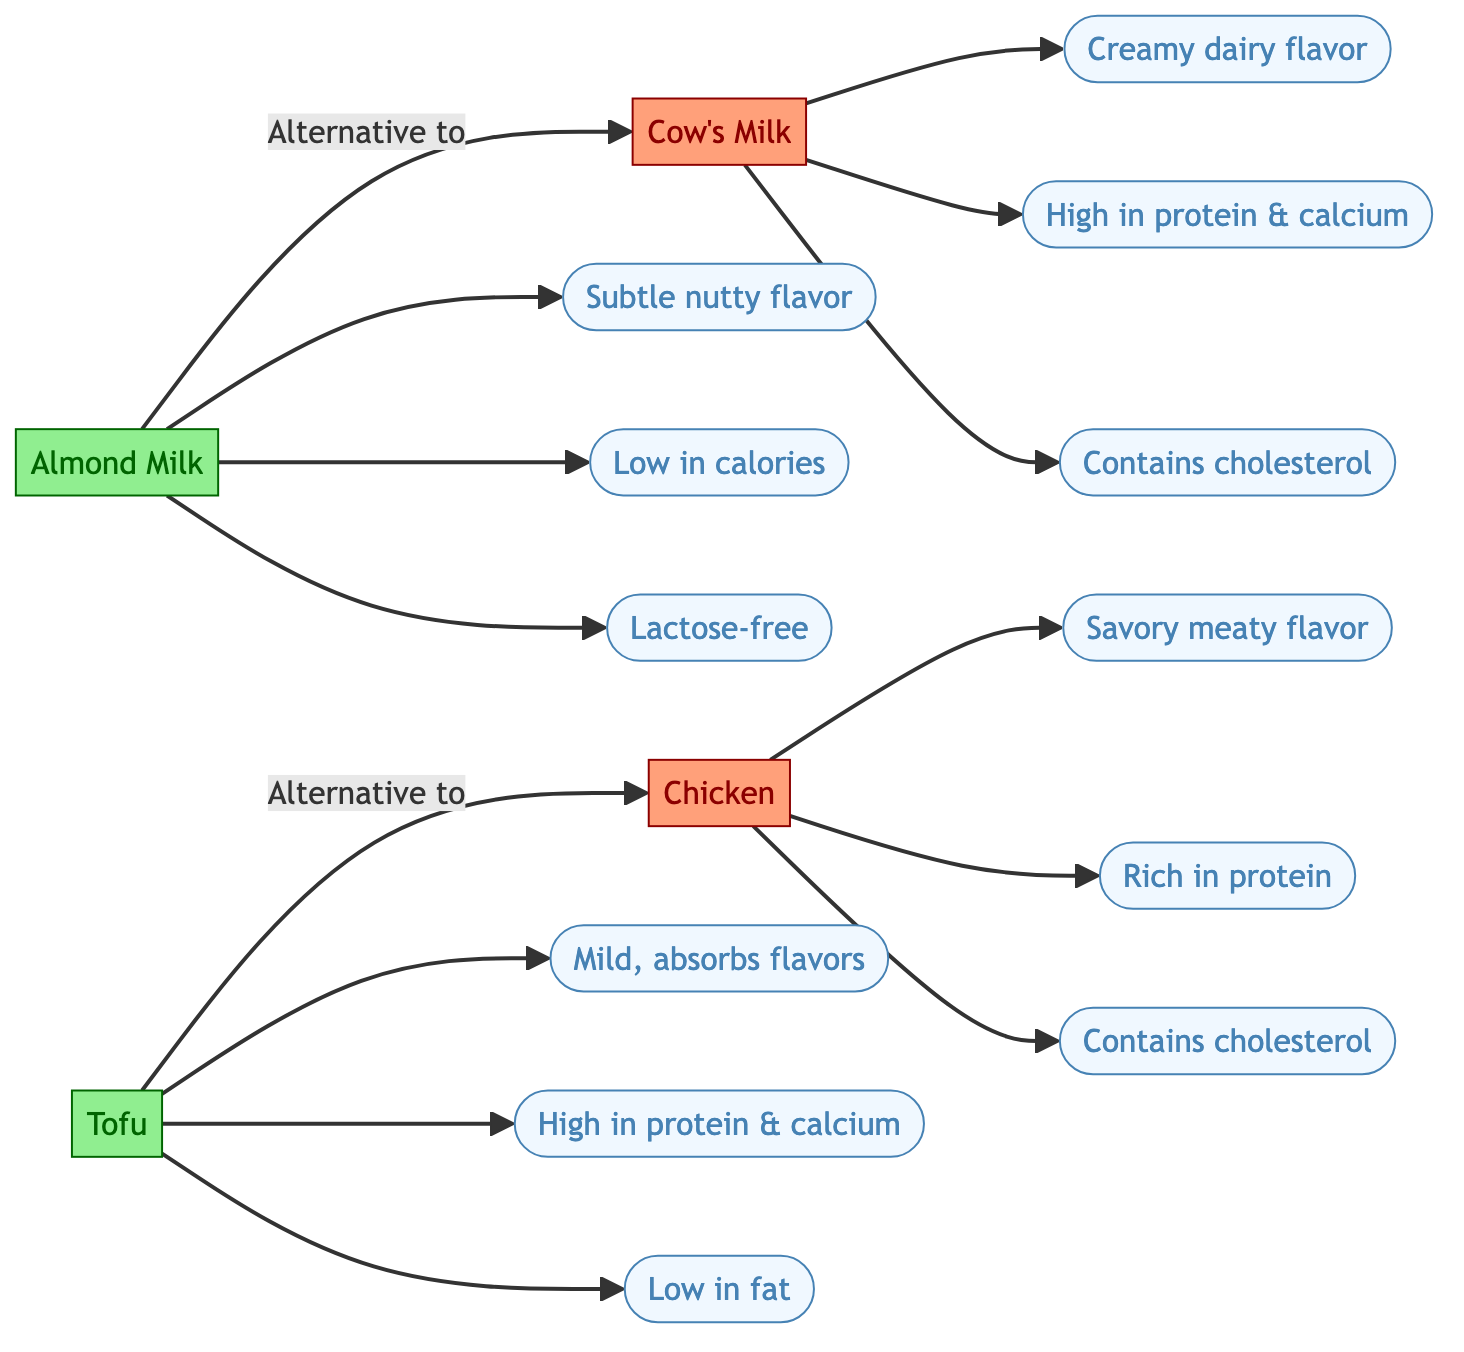What is the flavor profile of almond milk? The diagram indicates that almond milk has a "Subtle nutty flavor" as one of its features. This information can be found by tracing the direction from the almond milk node to its feature indicating flavor.
Answer: Subtle nutty flavor How many features does tofu have listed in the diagram? By counting the connections leading out from the tofu node, we can see it points to three distinct features: "Mild, absorbs flavors," "High in protein & calcium," and "Low in fat." Therefore, the total number of features for tofu is three.
Answer: 3 What are the health-related concerns associated with cow's milk? The diagram indicates two health-related features of cow's milk: "Contains cholesterol" and "High in protein & calcium." By evaluating these aspects, we can conclude that one of the concerns is its cholesterol content.
Answer: Contains cholesterol Which vegan alternative is low in calories? The almond milk node indicates the feature "Low in calories." By following the connection from almond milk, we can identify it as a key aspect of this alternative to cow's milk.
Answer: Low in calories What is the primary protein-related feature of chicken? The diagram shows chicken has a feature listed as "Rich in protein." We follow the direction from the chicken node to find this specific information about its protein content.
Answer: Rich in protein What characteristic distinguishes tofu from chicken in terms of health benefits? Tofu is noted to be "Low in fat," contrasting with chicken that has no such feature, indicating that tofu provides a health benefit by being lower in fat content. This highlights a significant difference in their nutritional profiles.
Answer: Low in fat Which animal product is noted for having a creamy dairy flavor? Following the connections from the cow's milk node, we find the description "Creamy dairy flavor," which directly indicates this feature associated with cow's milk.
Answer: Creamy dairy flavor What flavor characteristic of tofu is mentioned in the diagram? The diagram states that tofu has the flavor aspect of "Mild, absorbs flavors." By observing the connection from the tofu node to its feature, we can determine this information.
Answer: Mild, absorbs flavors 